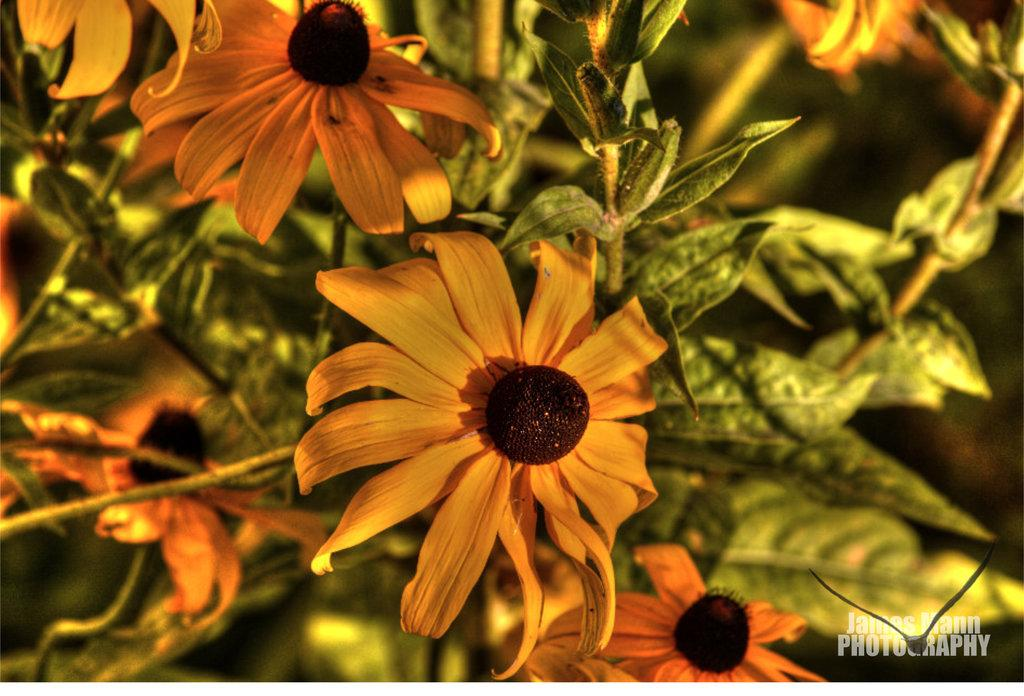What type of plant can be seen in the image? There is a flower plant in the image. What type of van is parked near the flower plant in the image? There is no van present in the image; it only features a flower plant. Can you tell me how many noses are visible on the flower plant in the image? There are no noses visible on the flower plant in the image, as it is a plant and not an animal or human. 